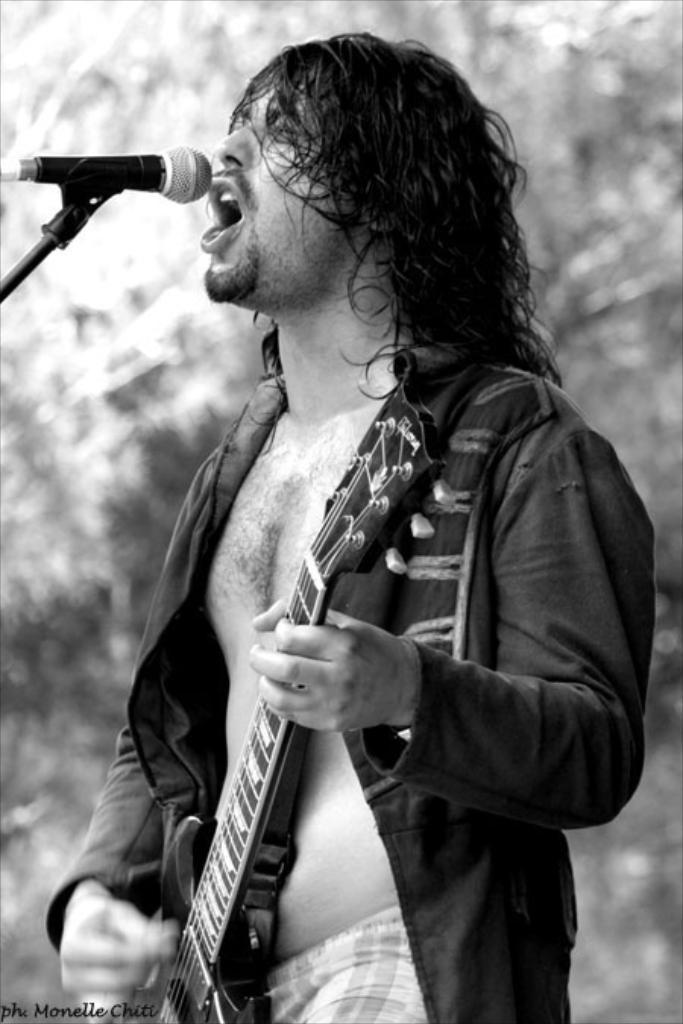Who is the main subject in the image? There is a man in the image. What is the man doing in the image? The man is singing and playing a guitar. What object is present in the image that is typically used for amplifying sound? There is a microphone in the image. Can you see a frog playing a trick on the man with a rod in the image? No, there is no frog, trick, or rod present in the image. 